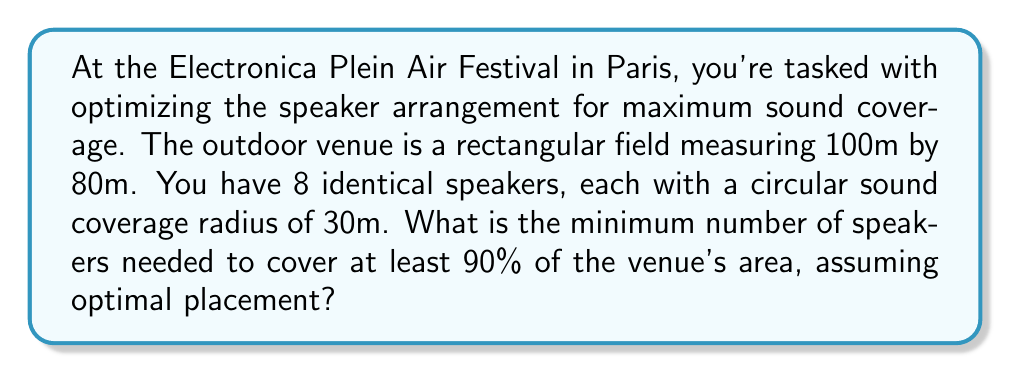Can you answer this question? Let's approach this step-by-step:

1) First, calculate the total area of the venue:
   $$ A_{venue} = 100m \times 80m = 8000m^2 $$

2) Calculate the area covered by one speaker:
   $$ A_{speaker} = \pi r^2 = \pi (30m)^2 \approx 2827.43m^2 $$

3) To cover 90% of the venue, we need to cover at least:
   $$ A_{required} = 0.90 \times 8000m^2 = 7200m^2 $$

4) If we divide the required area by the area of one speaker, we get:
   $$ \frac{A_{required}}{A_{speaker}} = \frac{7200m^2}{2827.43m^2} \approx 2.55 $$

5) This might suggest we need 3 speakers, but we need to consider overlap and edge effects. In reality, circular coverage patterns don't perfectly tessellate, especially in a rectangular space.

6) To account for this, we can use a packing efficiency factor. For circular packing in a rectangular space, a reasonable efficiency factor is about 0.8.

7) Applying this factor:
   $$ N_{speakers} = \frac{A_{required}}{A_{speaker} \times 0.8} = \frac{7200m^2}{2827.43m^2 \times 0.8} \approx 3.18 $$

8) Rounding up, we get 4 speakers as the minimum number needed.

9) To verify, we can calculate the total coverage:
   $$ A_{total} = 4 \times 2827.43m^2 \times 0.8 = 9047.78m^2 $$
   Which is indeed greater than 90% of the venue area.

The optimal placement would likely be near the corners of the rectangular field, allowing for overlap in the center and coverage of the edges.
Answer: 4 speakers 